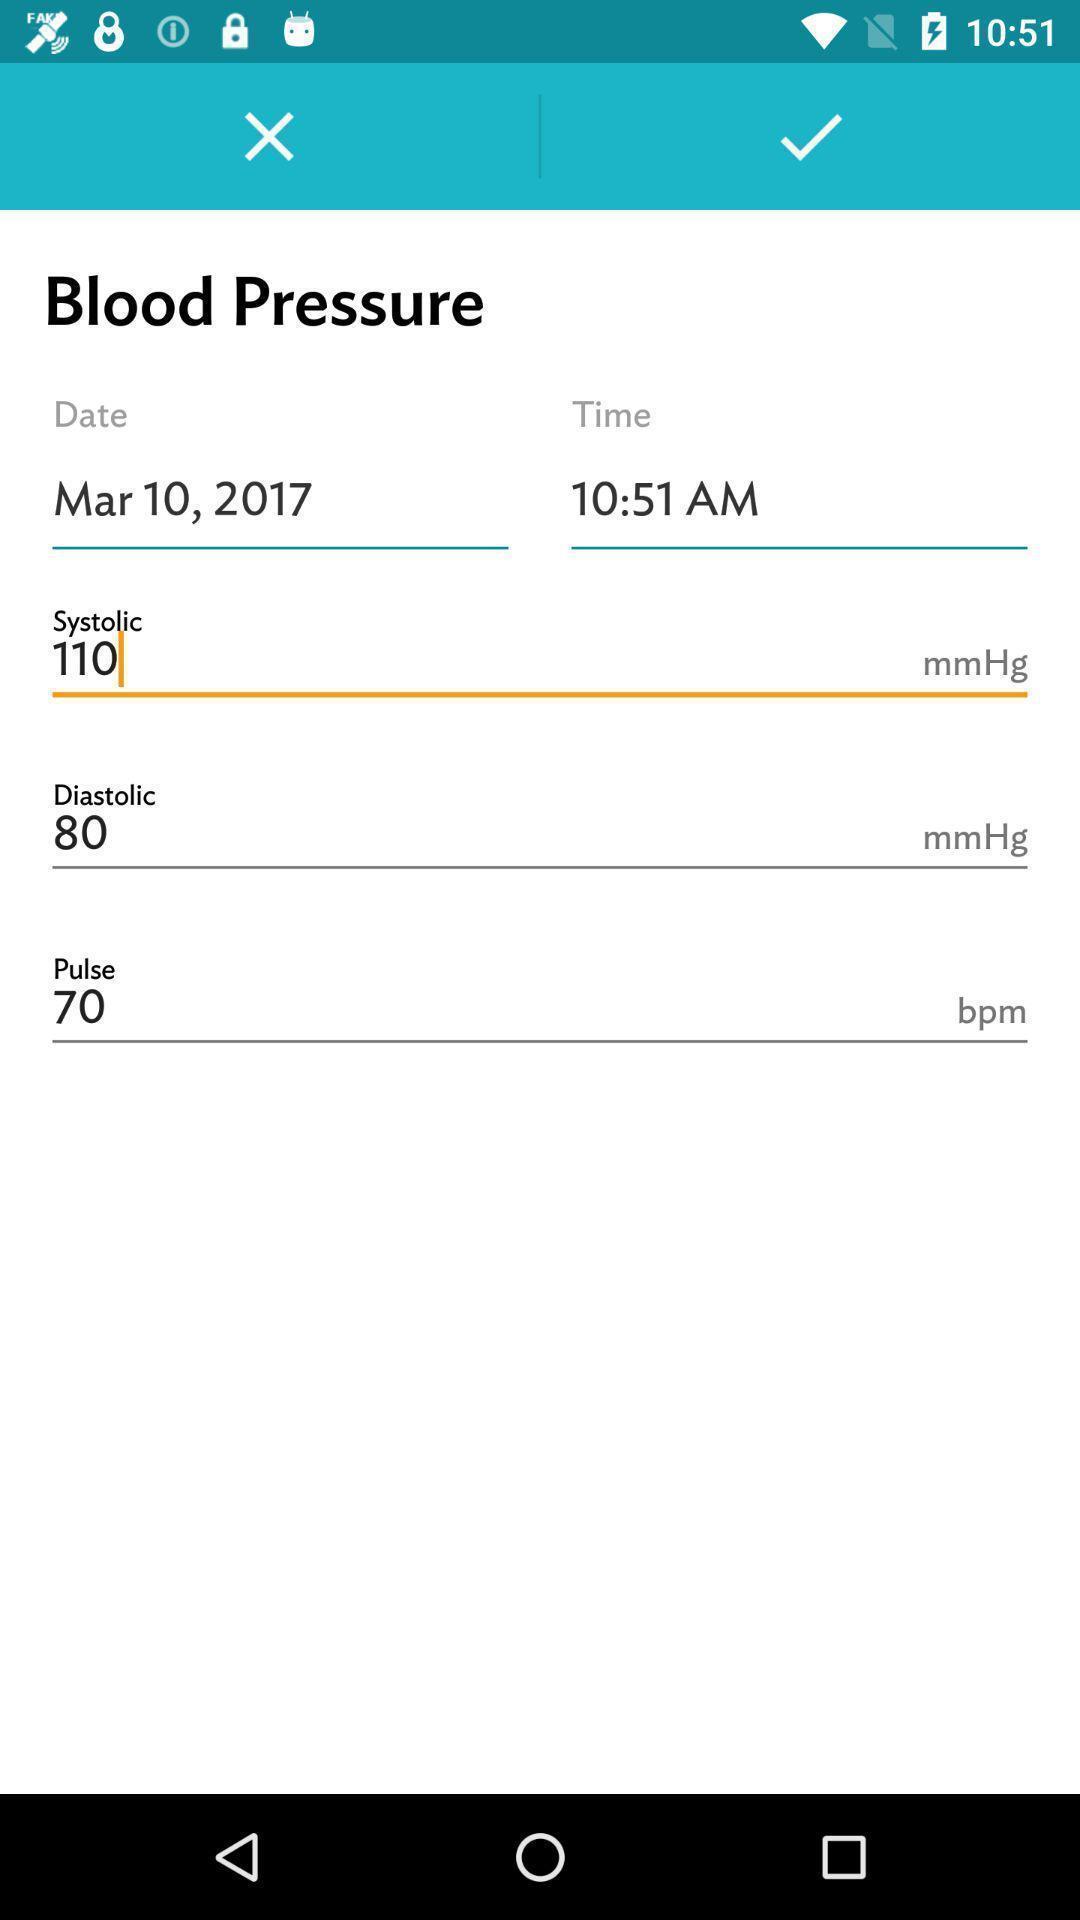Describe the key features of this screenshot. Page with details of blood pressure levels. 